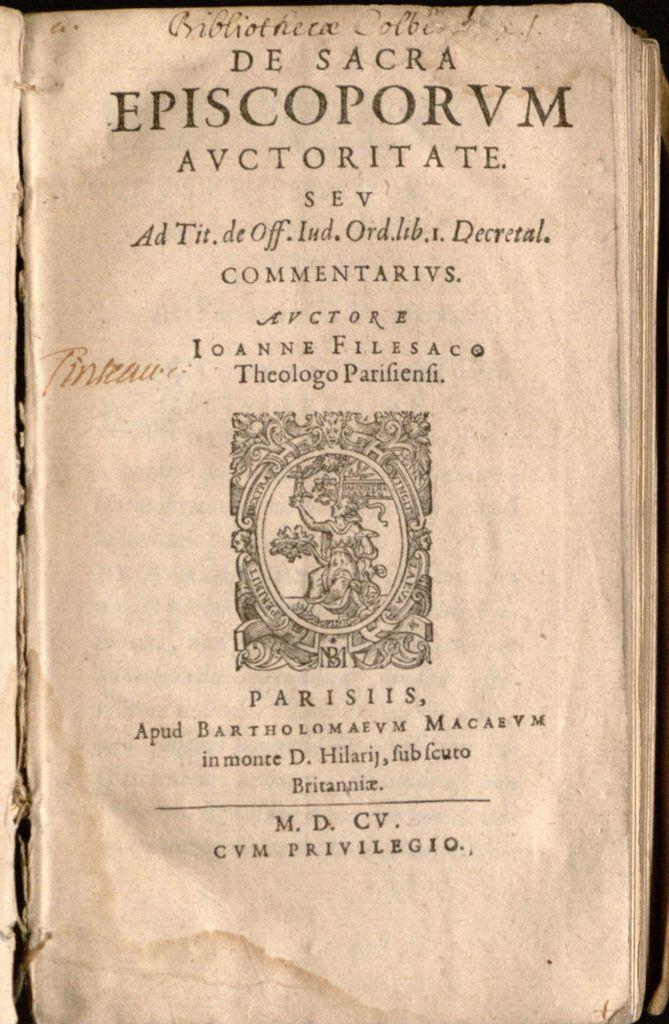Provide a one-sentence caption for the provided image. A cover page for an old book with the text episcoporum in bold at the top. 